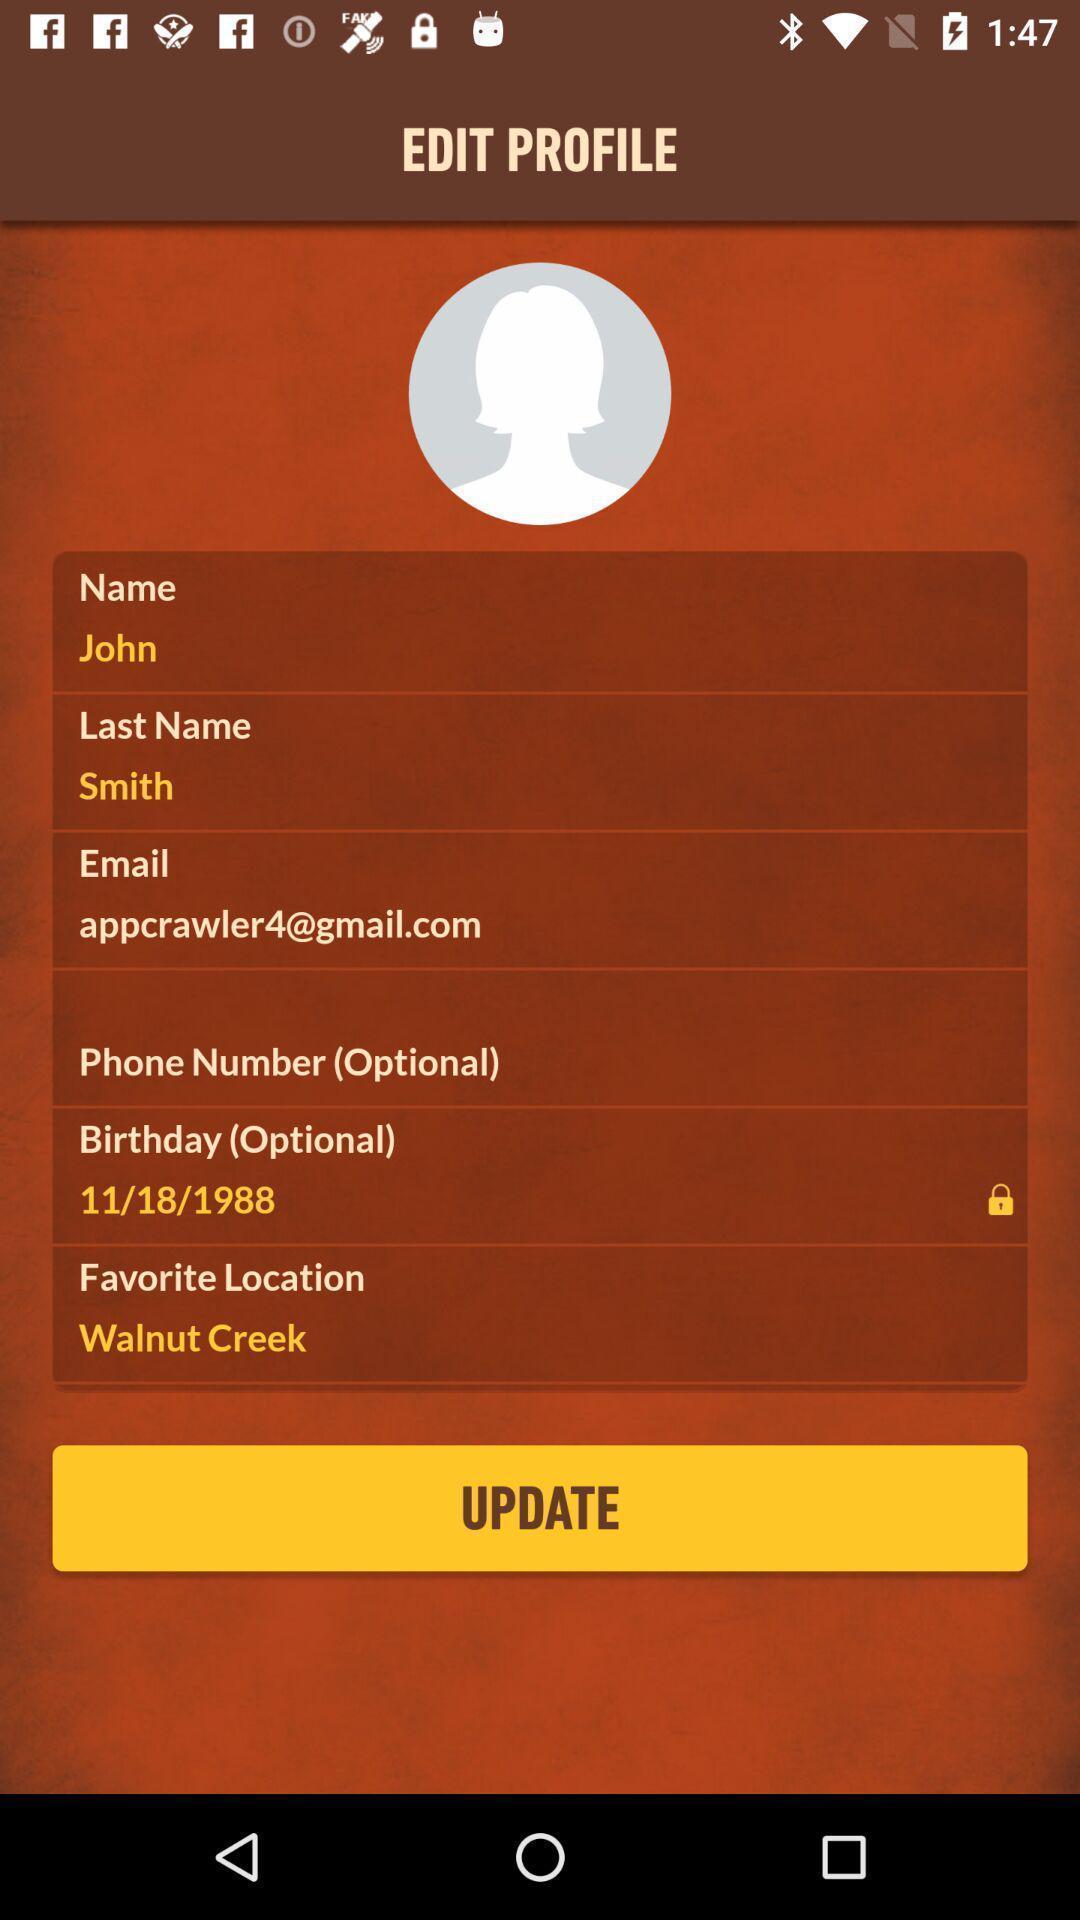Explain what's happening in this screen capture. Page showing the edit profile. 